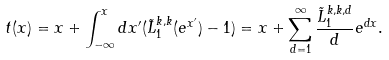Convert formula to latex. <formula><loc_0><loc_0><loc_500><loc_500>t ( x ) = x + \int _ { - \infty } ^ { x } d x ^ { \prime } ( { \tilde { L } ^ { k , k } _ { 1 } ( e ^ { x ^ { \prime } } ) } - 1 ) = x + \sum _ { d = 1 } ^ { \infty } \frac { \tilde { L } ^ { k , k , d } _ { 1 } } { d } e ^ { d x } .</formula> 